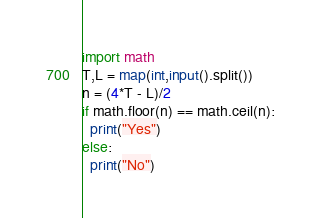<code> <loc_0><loc_0><loc_500><loc_500><_Python_>import math
T,L = map(int,input().split())
n = (4*T - L)/2
if math.floor(n) == math.ceil(n):
  print("Yes")
else:
  print("No")</code> 